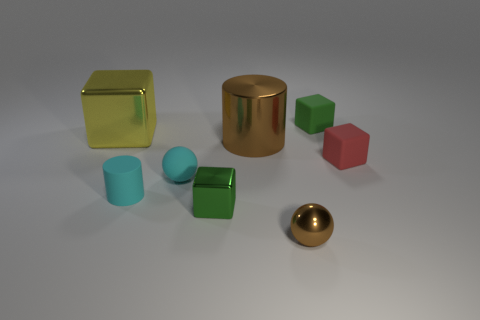What is the shape of the metallic thing that is the same size as the yellow cube?
Your response must be concise. Cylinder. Is the number of cyan rubber objects that are to the right of the yellow metallic block the same as the number of small matte blocks behind the tiny cylinder?
Make the answer very short. Yes. Is the material of the small green thing that is behind the cyan rubber cylinder the same as the small cyan ball?
Your response must be concise. Yes. There is a brown ball that is the same size as the red cube; what material is it?
Offer a terse response. Metal. What number of other objects are the same material as the brown ball?
Ensure brevity in your answer.  3. There is a cyan rubber ball; is its size the same as the green block that is on the left side of the small brown thing?
Your answer should be very brief. Yes. Is the number of rubber blocks that are on the right side of the small metallic cube less than the number of metal objects right of the cyan sphere?
Ensure brevity in your answer.  Yes. What is the size of the shiny block in front of the yellow block?
Give a very brief answer. Small. Does the green shiny object have the same size as the green matte cube?
Provide a short and direct response. Yes. How many objects are both in front of the big yellow shiny cube and on the right side of the metal cylinder?
Offer a very short reply. 2. 